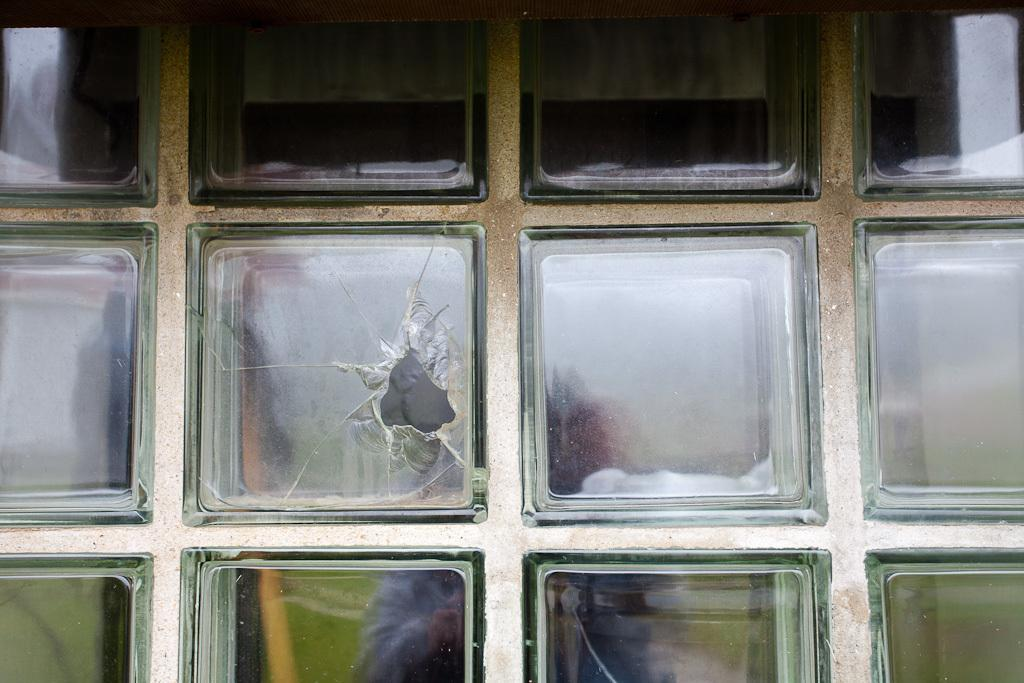What is the condition of the glass wall in the image? The glass wall in the image is broken. What can be seen on the broken glass wall? There are reflections visible on the broken glass wall. What type of leaf is falling from the fan in the image? There is no fan or leaf present in the image. 